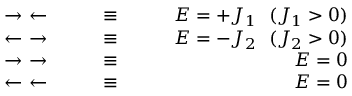<formula> <loc_0><loc_0><loc_500><loc_500>\begin{array} { r l r } { \rightarrow \leftarrow } & { \equiv } & { E = + J _ { 1 } ( J _ { 1 } > 0 ) } \\ { \leftarrow \rightarrow } & { \equiv } & { E = - J _ { 2 } ( J _ { 2 } > 0 ) } \\ { \rightarrow \rightarrow } & { \equiv } & { E = 0 } \\ { \leftarrow \leftarrow } & { \equiv } & { E = 0 } \end{array}</formula> 